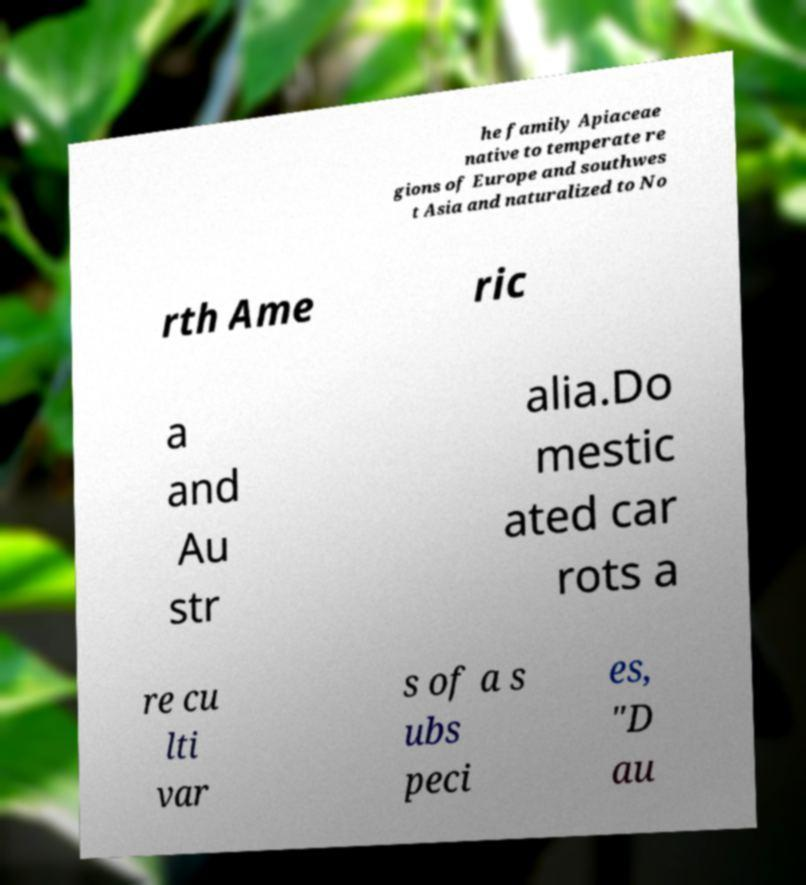Please identify and transcribe the text found in this image. he family Apiaceae native to temperate re gions of Europe and southwes t Asia and naturalized to No rth Ame ric a and Au str alia.Do mestic ated car rots a re cu lti var s of a s ubs peci es, "D au 